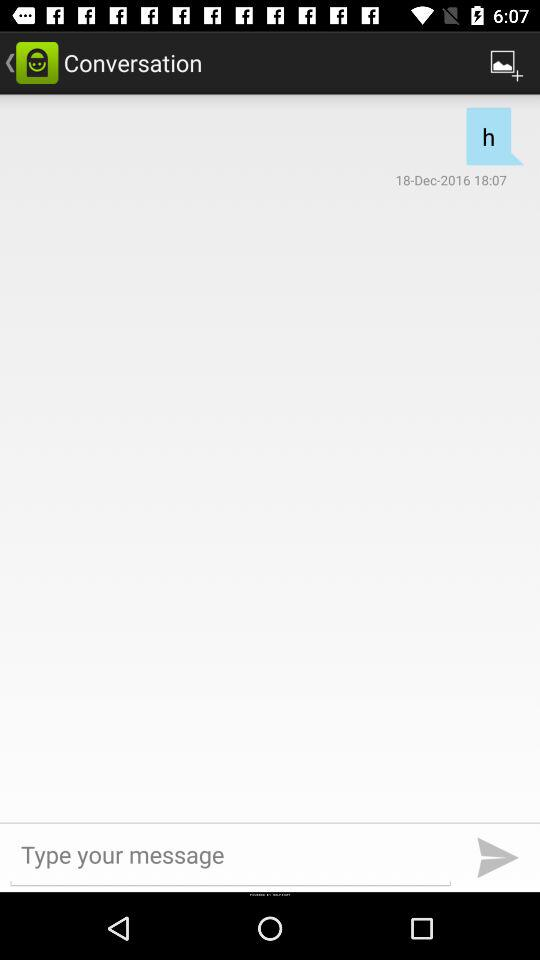What's the delivered message date and time? The delivered message date is December 18, 2016 and the time is 18:07. 